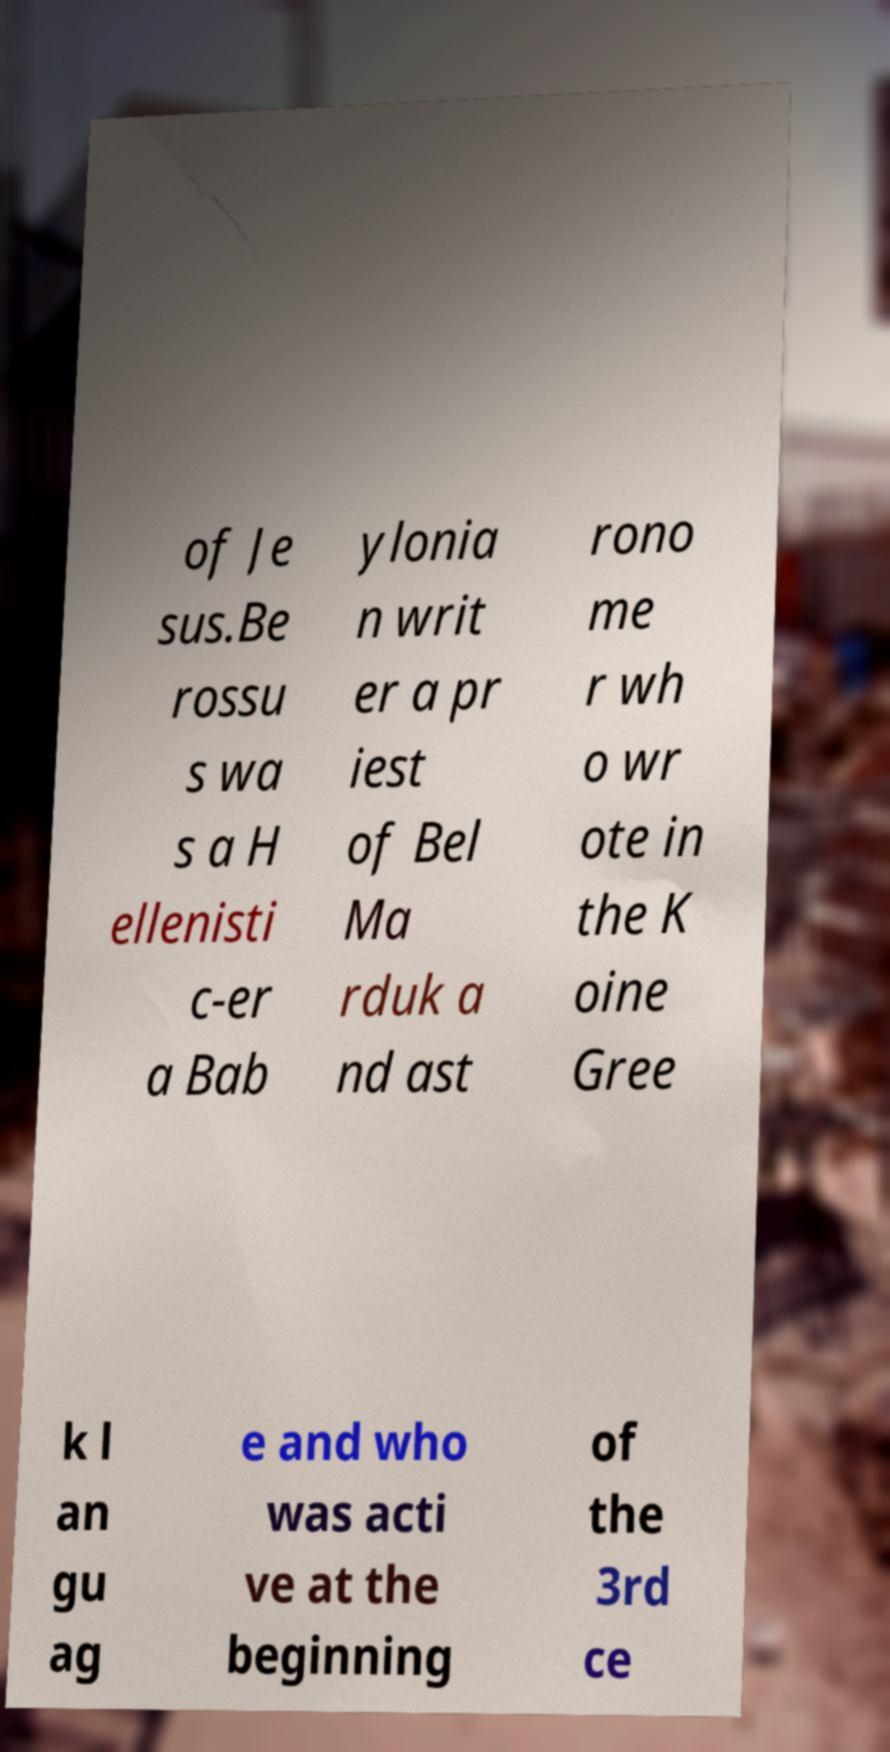I need the written content from this picture converted into text. Can you do that? of Je sus.Be rossu s wa s a H ellenisti c-er a Bab ylonia n writ er a pr iest of Bel Ma rduk a nd ast rono me r wh o wr ote in the K oine Gree k l an gu ag e and who was acti ve at the beginning of the 3rd ce 